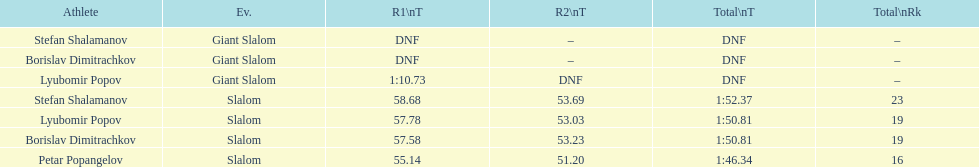Who has the highest rank? Petar Popangelov. 